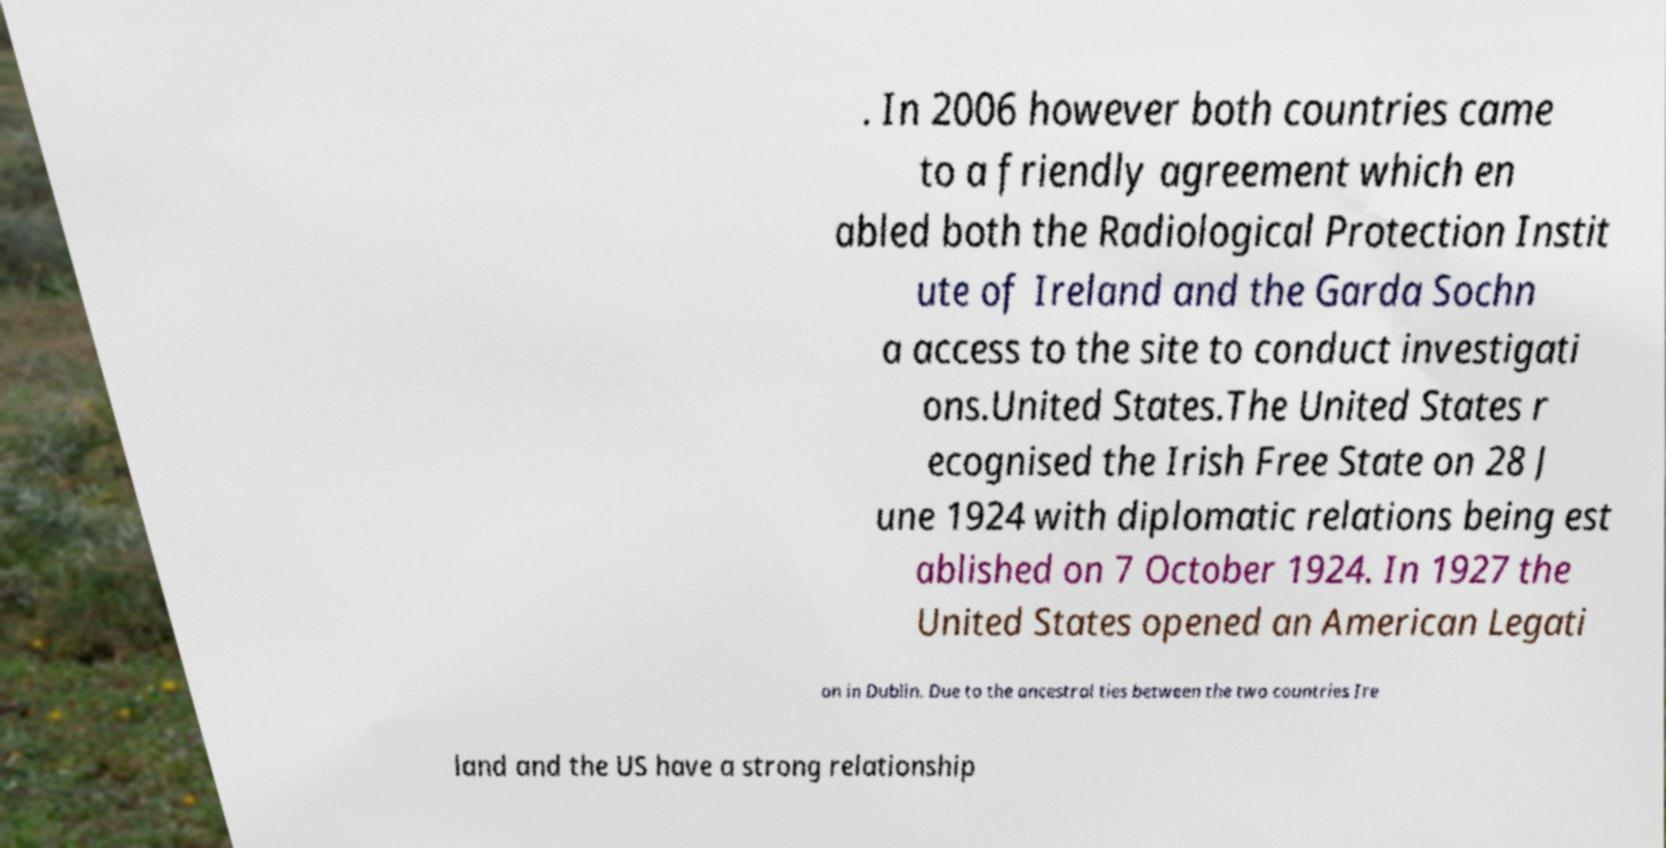What messages or text are displayed in this image? I need them in a readable, typed format. . In 2006 however both countries came to a friendly agreement which en abled both the Radiological Protection Instit ute of Ireland and the Garda Sochn a access to the site to conduct investigati ons.United States.The United States r ecognised the Irish Free State on 28 J une 1924 with diplomatic relations being est ablished on 7 October 1924. In 1927 the United States opened an American Legati on in Dublin. Due to the ancestral ties between the two countries Ire land and the US have a strong relationship 